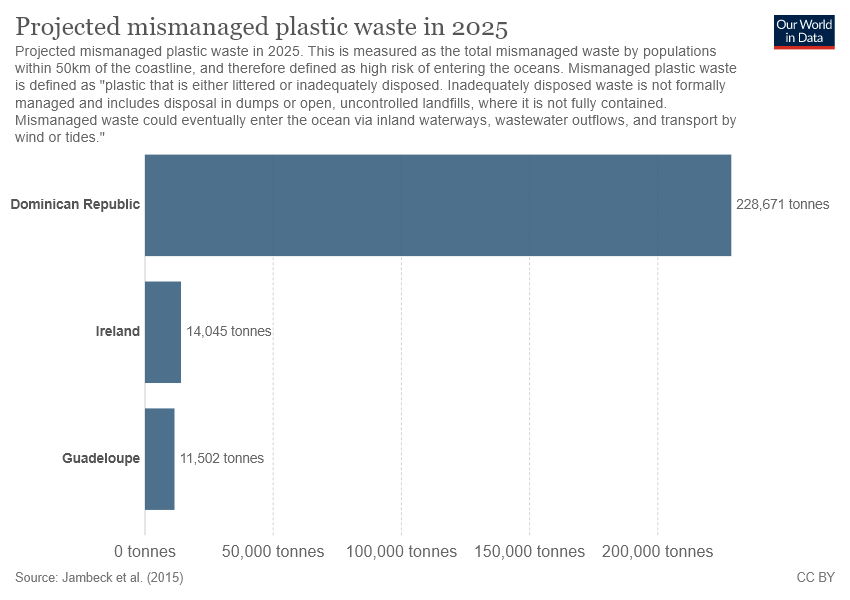Give some essential details in this illustration. The highest value in the chart is 228,671. The sum of Ireland and Guadeloupe is 25547. 